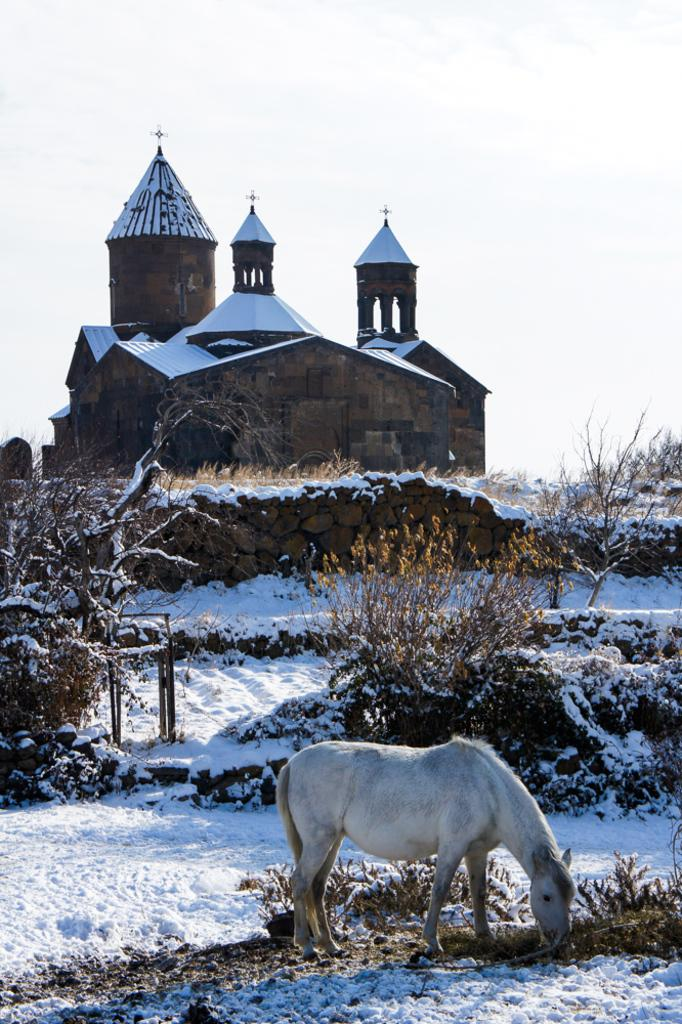What is covering the ground in the image? There is snow on the ground in the image. What animal can be seen on the right side of the image? There is a horse on the right side of the image. What can be seen in the background of the image? There are plants, a wall, and a house in the background of the image. What is visible at the top of the image? The sky is visible at the top of the image. How many girls are playing with the curve in the image? There are no girls or curves present in the image. What type of building is visible in the background of the image? There is no building visible in the background of the image; only a house, plants, and a wall are present. 